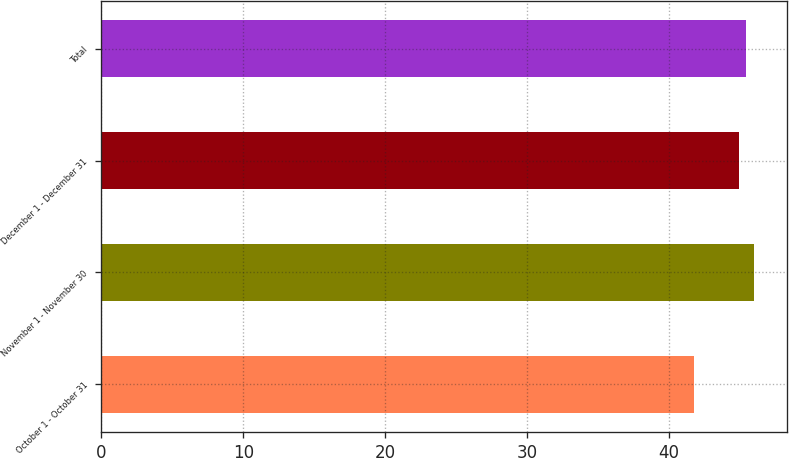Convert chart to OTSL. <chart><loc_0><loc_0><loc_500><loc_500><bar_chart><fcel>October 1 - October 31<fcel>November 1 - November 30<fcel>December 1 - December 31<fcel>Total<nl><fcel>41.78<fcel>45.99<fcel>44.94<fcel>45.41<nl></chart> 